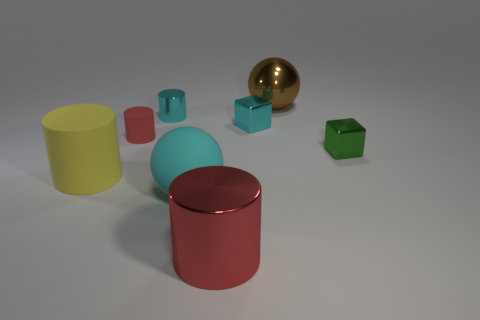There is a metallic thing that is both behind the big cyan ball and in front of the tiny red rubber thing; what size is it?
Provide a short and direct response. Small. What number of small objects are either yellow cylinders or gray metallic cylinders?
Your answer should be compact. 0. The big object behind the large matte cylinder has what shape?
Ensure brevity in your answer.  Sphere. What number of big brown things are there?
Provide a short and direct response. 1. Is the material of the big red cylinder the same as the large yellow thing?
Your answer should be very brief. No. Is the number of big brown things behind the small matte cylinder greater than the number of tiny purple matte blocks?
Offer a terse response. Yes. What number of things are either green metallic blocks or blocks on the right side of the small cyan metal block?
Ensure brevity in your answer.  1. Are there more large objects that are to the left of the large cyan object than red metal things to the left of the small red rubber cylinder?
Ensure brevity in your answer.  Yes. There is a red cylinder to the right of the small cyan metallic thing that is left of the large metallic object that is in front of the big brown ball; what is its material?
Give a very brief answer. Metal. The other large thing that is made of the same material as the big brown object is what shape?
Your answer should be very brief. Cylinder. 